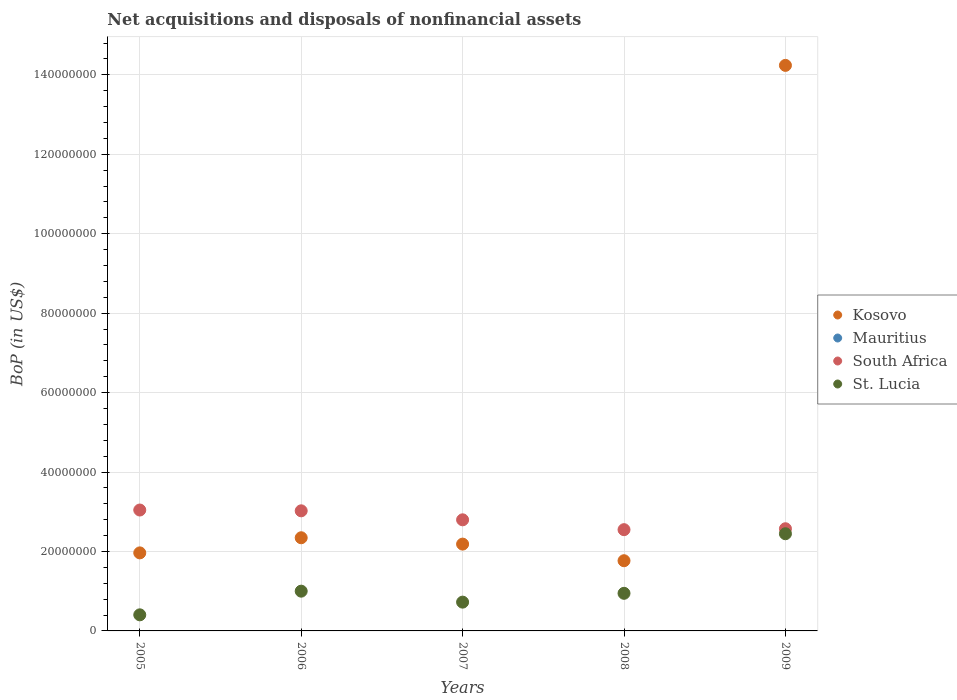How many different coloured dotlines are there?
Your answer should be very brief. 3. What is the Balance of Payments in South Africa in 2007?
Offer a terse response. 2.80e+07. Across all years, what is the maximum Balance of Payments in South Africa?
Your response must be concise. 3.04e+07. Across all years, what is the minimum Balance of Payments in St. Lucia?
Your response must be concise. 4.05e+06. What is the total Balance of Payments in South Africa in the graph?
Your answer should be very brief. 1.40e+08. What is the difference between the Balance of Payments in Kosovo in 2007 and that in 2008?
Offer a terse response. 4.18e+06. What is the difference between the Balance of Payments in Mauritius in 2005 and the Balance of Payments in St. Lucia in 2008?
Your answer should be compact. -9.47e+06. What is the average Balance of Payments in St. Lucia per year?
Your answer should be very brief. 1.10e+07. In the year 2009, what is the difference between the Balance of Payments in St. Lucia and Balance of Payments in South Africa?
Keep it short and to the point. -1.26e+06. What is the ratio of the Balance of Payments in St. Lucia in 2006 to that in 2009?
Your response must be concise. 0.41. Is the Balance of Payments in St. Lucia in 2005 less than that in 2006?
Your answer should be compact. Yes. Is the difference between the Balance of Payments in St. Lucia in 2008 and 2009 greater than the difference between the Balance of Payments in South Africa in 2008 and 2009?
Make the answer very short. No. What is the difference between the highest and the second highest Balance of Payments in Kosovo?
Your answer should be compact. 1.19e+08. What is the difference between the highest and the lowest Balance of Payments in St. Lucia?
Provide a succinct answer. 2.04e+07. Is the sum of the Balance of Payments in Kosovo in 2005 and 2009 greater than the maximum Balance of Payments in South Africa across all years?
Offer a terse response. Yes. Is it the case that in every year, the sum of the Balance of Payments in Kosovo and Balance of Payments in St. Lucia  is greater than the sum of Balance of Payments in Mauritius and Balance of Payments in South Africa?
Ensure brevity in your answer.  No. Does the Balance of Payments in Kosovo monotonically increase over the years?
Your response must be concise. No. Is the Balance of Payments in Kosovo strictly greater than the Balance of Payments in Mauritius over the years?
Your response must be concise. Yes. How many dotlines are there?
Give a very brief answer. 3. What is the difference between two consecutive major ticks on the Y-axis?
Your response must be concise. 2.00e+07. Does the graph contain any zero values?
Make the answer very short. Yes. Where does the legend appear in the graph?
Your response must be concise. Center right. How many legend labels are there?
Your response must be concise. 4. How are the legend labels stacked?
Your answer should be very brief. Vertical. What is the title of the graph?
Your answer should be compact. Net acquisitions and disposals of nonfinancial assets. Does "United States" appear as one of the legend labels in the graph?
Your answer should be compact. No. What is the label or title of the X-axis?
Your answer should be compact. Years. What is the label or title of the Y-axis?
Offer a very short reply. BoP (in US$). What is the BoP (in US$) of Kosovo in 2005?
Your response must be concise. 1.96e+07. What is the BoP (in US$) of South Africa in 2005?
Ensure brevity in your answer.  3.04e+07. What is the BoP (in US$) in St. Lucia in 2005?
Keep it short and to the point. 4.05e+06. What is the BoP (in US$) of Kosovo in 2006?
Your answer should be very brief. 2.35e+07. What is the BoP (in US$) of Mauritius in 2006?
Provide a succinct answer. 0. What is the BoP (in US$) in South Africa in 2006?
Make the answer very short. 3.02e+07. What is the BoP (in US$) of St. Lucia in 2006?
Give a very brief answer. 1.00e+07. What is the BoP (in US$) in Kosovo in 2007?
Provide a succinct answer. 2.19e+07. What is the BoP (in US$) of Mauritius in 2007?
Provide a succinct answer. 0. What is the BoP (in US$) of South Africa in 2007?
Your response must be concise. 2.80e+07. What is the BoP (in US$) of St. Lucia in 2007?
Your answer should be very brief. 7.25e+06. What is the BoP (in US$) in Kosovo in 2008?
Your answer should be compact. 1.77e+07. What is the BoP (in US$) in Mauritius in 2008?
Keep it short and to the point. 0. What is the BoP (in US$) of South Africa in 2008?
Offer a very short reply. 2.55e+07. What is the BoP (in US$) in St. Lucia in 2008?
Make the answer very short. 9.47e+06. What is the BoP (in US$) in Kosovo in 2009?
Provide a succinct answer. 1.42e+08. What is the BoP (in US$) of Mauritius in 2009?
Your response must be concise. 0. What is the BoP (in US$) of South Africa in 2009?
Provide a succinct answer. 2.57e+07. What is the BoP (in US$) of St. Lucia in 2009?
Your response must be concise. 2.45e+07. Across all years, what is the maximum BoP (in US$) in Kosovo?
Give a very brief answer. 1.42e+08. Across all years, what is the maximum BoP (in US$) in South Africa?
Provide a succinct answer. 3.04e+07. Across all years, what is the maximum BoP (in US$) in St. Lucia?
Your answer should be compact. 2.45e+07. Across all years, what is the minimum BoP (in US$) of Kosovo?
Give a very brief answer. 1.77e+07. Across all years, what is the minimum BoP (in US$) of South Africa?
Make the answer very short. 2.55e+07. Across all years, what is the minimum BoP (in US$) of St. Lucia?
Give a very brief answer. 4.05e+06. What is the total BoP (in US$) of Kosovo in the graph?
Give a very brief answer. 2.25e+08. What is the total BoP (in US$) in Mauritius in the graph?
Make the answer very short. 0. What is the total BoP (in US$) in South Africa in the graph?
Offer a very short reply. 1.40e+08. What is the total BoP (in US$) of St. Lucia in the graph?
Ensure brevity in your answer.  5.52e+07. What is the difference between the BoP (in US$) of Kosovo in 2005 and that in 2006?
Provide a short and direct response. -3.81e+06. What is the difference between the BoP (in US$) in South Africa in 2005 and that in 2006?
Keep it short and to the point. 2.02e+05. What is the difference between the BoP (in US$) of St. Lucia in 2005 and that in 2006?
Offer a terse response. -5.96e+06. What is the difference between the BoP (in US$) of Kosovo in 2005 and that in 2007?
Offer a very short reply. -2.21e+06. What is the difference between the BoP (in US$) in South Africa in 2005 and that in 2007?
Make the answer very short. 2.47e+06. What is the difference between the BoP (in US$) in St. Lucia in 2005 and that in 2007?
Your response must be concise. -3.20e+06. What is the difference between the BoP (in US$) in Kosovo in 2005 and that in 2008?
Provide a succinct answer. 1.97e+06. What is the difference between the BoP (in US$) of South Africa in 2005 and that in 2008?
Offer a very short reply. 4.95e+06. What is the difference between the BoP (in US$) in St. Lucia in 2005 and that in 2008?
Make the answer very short. -5.42e+06. What is the difference between the BoP (in US$) of Kosovo in 2005 and that in 2009?
Your answer should be compact. -1.23e+08. What is the difference between the BoP (in US$) in South Africa in 2005 and that in 2009?
Give a very brief answer. 4.71e+06. What is the difference between the BoP (in US$) in St. Lucia in 2005 and that in 2009?
Ensure brevity in your answer.  -2.04e+07. What is the difference between the BoP (in US$) in Kosovo in 2006 and that in 2007?
Make the answer very short. 1.60e+06. What is the difference between the BoP (in US$) in South Africa in 2006 and that in 2007?
Provide a succinct answer. 2.26e+06. What is the difference between the BoP (in US$) of St. Lucia in 2006 and that in 2007?
Offer a very short reply. 2.76e+06. What is the difference between the BoP (in US$) in Kosovo in 2006 and that in 2008?
Provide a short and direct response. 5.78e+06. What is the difference between the BoP (in US$) in South Africa in 2006 and that in 2008?
Provide a succinct answer. 4.74e+06. What is the difference between the BoP (in US$) of St. Lucia in 2006 and that in 2008?
Ensure brevity in your answer.  5.42e+05. What is the difference between the BoP (in US$) in Kosovo in 2006 and that in 2009?
Your answer should be compact. -1.19e+08. What is the difference between the BoP (in US$) of South Africa in 2006 and that in 2009?
Give a very brief answer. 4.51e+06. What is the difference between the BoP (in US$) in St. Lucia in 2006 and that in 2009?
Give a very brief answer. -1.45e+07. What is the difference between the BoP (in US$) in Kosovo in 2007 and that in 2008?
Give a very brief answer. 4.18e+06. What is the difference between the BoP (in US$) of South Africa in 2007 and that in 2008?
Keep it short and to the point. 2.48e+06. What is the difference between the BoP (in US$) in St. Lucia in 2007 and that in 2008?
Offer a terse response. -2.22e+06. What is the difference between the BoP (in US$) of Kosovo in 2007 and that in 2009?
Your response must be concise. -1.21e+08. What is the difference between the BoP (in US$) of South Africa in 2007 and that in 2009?
Give a very brief answer. 2.25e+06. What is the difference between the BoP (in US$) of St. Lucia in 2007 and that in 2009?
Offer a terse response. -1.72e+07. What is the difference between the BoP (in US$) of Kosovo in 2008 and that in 2009?
Provide a succinct answer. -1.25e+08. What is the difference between the BoP (in US$) of South Africa in 2008 and that in 2009?
Your answer should be compact. -2.34e+05. What is the difference between the BoP (in US$) in St. Lucia in 2008 and that in 2009?
Your response must be concise. -1.50e+07. What is the difference between the BoP (in US$) in Kosovo in 2005 and the BoP (in US$) in South Africa in 2006?
Give a very brief answer. -1.06e+07. What is the difference between the BoP (in US$) in Kosovo in 2005 and the BoP (in US$) in St. Lucia in 2006?
Provide a short and direct response. 9.64e+06. What is the difference between the BoP (in US$) in South Africa in 2005 and the BoP (in US$) in St. Lucia in 2006?
Your answer should be very brief. 2.04e+07. What is the difference between the BoP (in US$) in Kosovo in 2005 and the BoP (in US$) in South Africa in 2007?
Offer a terse response. -8.33e+06. What is the difference between the BoP (in US$) of Kosovo in 2005 and the BoP (in US$) of St. Lucia in 2007?
Your answer should be compact. 1.24e+07. What is the difference between the BoP (in US$) in South Africa in 2005 and the BoP (in US$) in St. Lucia in 2007?
Offer a terse response. 2.32e+07. What is the difference between the BoP (in US$) of Kosovo in 2005 and the BoP (in US$) of South Africa in 2008?
Offer a terse response. -5.85e+06. What is the difference between the BoP (in US$) in Kosovo in 2005 and the BoP (in US$) in St. Lucia in 2008?
Your answer should be compact. 1.02e+07. What is the difference between the BoP (in US$) of South Africa in 2005 and the BoP (in US$) of St. Lucia in 2008?
Keep it short and to the point. 2.10e+07. What is the difference between the BoP (in US$) in Kosovo in 2005 and the BoP (in US$) in South Africa in 2009?
Offer a very short reply. -6.08e+06. What is the difference between the BoP (in US$) of Kosovo in 2005 and the BoP (in US$) of St. Lucia in 2009?
Offer a terse response. -4.82e+06. What is the difference between the BoP (in US$) of South Africa in 2005 and the BoP (in US$) of St. Lucia in 2009?
Offer a very short reply. 5.97e+06. What is the difference between the BoP (in US$) of Kosovo in 2006 and the BoP (in US$) of South Africa in 2007?
Offer a very short reply. -4.52e+06. What is the difference between the BoP (in US$) in Kosovo in 2006 and the BoP (in US$) in St. Lucia in 2007?
Make the answer very short. 1.62e+07. What is the difference between the BoP (in US$) of South Africa in 2006 and the BoP (in US$) of St. Lucia in 2007?
Offer a very short reply. 2.30e+07. What is the difference between the BoP (in US$) in Kosovo in 2006 and the BoP (in US$) in South Africa in 2008?
Provide a short and direct response. -2.04e+06. What is the difference between the BoP (in US$) of Kosovo in 2006 and the BoP (in US$) of St. Lucia in 2008?
Your answer should be very brief. 1.40e+07. What is the difference between the BoP (in US$) in South Africa in 2006 and the BoP (in US$) in St. Lucia in 2008?
Your answer should be compact. 2.08e+07. What is the difference between the BoP (in US$) in Kosovo in 2006 and the BoP (in US$) in South Africa in 2009?
Provide a succinct answer. -2.27e+06. What is the difference between the BoP (in US$) in Kosovo in 2006 and the BoP (in US$) in St. Lucia in 2009?
Offer a very short reply. -1.01e+06. What is the difference between the BoP (in US$) of South Africa in 2006 and the BoP (in US$) of St. Lucia in 2009?
Give a very brief answer. 5.77e+06. What is the difference between the BoP (in US$) in Kosovo in 2007 and the BoP (in US$) in South Africa in 2008?
Offer a very short reply. -3.64e+06. What is the difference between the BoP (in US$) of Kosovo in 2007 and the BoP (in US$) of St. Lucia in 2008?
Your answer should be compact. 1.24e+07. What is the difference between the BoP (in US$) of South Africa in 2007 and the BoP (in US$) of St. Lucia in 2008?
Make the answer very short. 1.85e+07. What is the difference between the BoP (in US$) of Kosovo in 2007 and the BoP (in US$) of South Africa in 2009?
Offer a terse response. -3.87e+06. What is the difference between the BoP (in US$) in Kosovo in 2007 and the BoP (in US$) in St. Lucia in 2009?
Keep it short and to the point. -2.61e+06. What is the difference between the BoP (in US$) of South Africa in 2007 and the BoP (in US$) of St. Lucia in 2009?
Your response must be concise. 3.51e+06. What is the difference between the BoP (in US$) of Kosovo in 2008 and the BoP (in US$) of South Africa in 2009?
Make the answer very short. -8.05e+06. What is the difference between the BoP (in US$) of Kosovo in 2008 and the BoP (in US$) of St. Lucia in 2009?
Give a very brief answer. -6.79e+06. What is the difference between the BoP (in US$) of South Africa in 2008 and the BoP (in US$) of St. Lucia in 2009?
Provide a short and direct response. 1.03e+06. What is the average BoP (in US$) in Kosovo per year?
Your response must be concise. 4.50e+07. What is the average BoP (in US$) of Mauritius per year?
Give a very brief answer. 0. What is the average BoP (in US$) in South Africa per year?
Ensure brevity in your answer.  2.80e+07. What is the average BoP (in US$) of St. Lucia per year?
Give a very brief answer. 1.10e+07. In the year 2005, what is the difference between the BoP (in US$) in Kosovo and BoP (in US$) in South Africa?
Keep it short and to the point. -1.08e+07. In the year 2005, what is the difference between the BoP (in US$) in Kosovo and BoP (in US$) in St. Lucia?
Your answer should be very brief. 1.56e+07. In the year 2005, what is the difference between the BoP (in US$) in South Africa and BoP (in US$) in St. Lucia?
Make the answer very short. 2.64e+07. In the year 2006, what is the difference between the BoP (in US$) of Kosovo and BoP (in US$) of South Africa?
Ensure brevity in your answer.  -6.78e+06. In the year 2006, what is the difference between the BoP (in US$) in Kosovo and BoP (in US$) in St. Lucia?
Your response must be concise. 1.34e+07. In the year 2006, what is the difference between the BoP (in US$) of South Africa and BoP (in US$) of St. Lucia?
Provide a succinct answer. 2.02e+07. In the year 2007, what is the difference between the BoP (in US$) in Kosovo and BoP (in US$) in South Africa?
Keep it short and to the point. -6.12e+06. In the year 2007, what is the difference between the BoP (in US$) of Kosovo and BoP (in US$) of St. Lucia?
Ensure brevity in your answer.  1.46e+07. In the year 2007, what is the difference between the BoP (in US$) in South Africa and BoP (in US$) in St. Lucia?
Offer a very short reply. 2.07e+07. In the year 2008, what is the difference between the BoP (in US$) in Kosovo and BoP (in US$) in South Africa?
Your response must be concise. -7.82e+06. In the year 2008, what is the difference between the BoP (in US$) in Kosovo and BoP (in US$) in St. Lucia?
Your response must be concise. 8.21e+06. In the year 2008, what is the difference between the BoP (in US$) of South Africa and BoP (in US$) of St. Lucia?
Ensure brevity in your answer.  1.60e+07. In the year 2009, what is the difference between the BoP (in US$) in Kosovo and BoP (in US$) in South Africa?
Offer a terse response. 1.17e+08. In the year 2009, what is the difference between the BoP (in US$) of Kosovo and BoP (in US$) of St. Lucia?
Your response must be concise. 1.18e+08. In the year 2009, what is the difference between the BoP (in US$) in South Africa and BoP (in US$) in St. Lucia?
Provide a short and direct response. 1.26e+06. What is the ratio of the BoP (in US$) in Kosovo in 2005 to that in 2006?
Give a very brief answer. 0.84. What is the ratio of the BoP (in US$) of St. Lucia in 2005 to that in 2006?
Offer a terse response. 0.4. What is the ratio of the BoP (in US$) in Kosovo in 2005 to that in 2007?
Give a very brief answer. 0.9. What is the ratio of the BoP (in US$) of South Africa in 2005 to that in 2007?
Provide a short and direct response. 1.09. What is the ratio of the BoP (in US$) of St. Lucia in 2005 to that in 2007?
Offer a very short reply. 0.56. What is the ratio of the BoP (in US$) of Kosovo in 2005 to that in 2008?
Keep it short and to the point. 1.11. What is the ratio of the BoP (in US$) in South Africa in 2005 to that in 2008?
Offer a terse response. 1.19. What is the ratio of the BoP (in US$) of St. Lucia in 2005 to that in 2008?
Provide a succinct answer. 0.43. What is the ratio of the BoP (in US$) of Kosovo in 2005 to that in 2009?
Offer a very short reply. 0.14. What is the ratio of the BoP (in US$) of South Africa in 2005 to that in 2009?
Ensure brevity in your answer.  1.18. What is the ratio of the BoP (in US$) in St. Lucia in 2005 to that in 2009?
Your answer should be very brief. 0.17. What is the ratio of the BoP (in US$) in Kosovo in 2006 to that in 2007?
Provide a succinct answer. 1.07. What is the ratio of the BoP (in US$) of South Africa in 2006 to that in 2007?
Provide a short and direct response. 1.08. What is the ratio of the BoP (in US$) in St. Lucia in 2006 to that in 2007?
Offer a terse response. 1.38. What is the ratio of the BoP (in US$) of Kosovo in 2006 to that in 2008?
Your answer should be very brief. 1.33. What is the ratio of the BoP (in US$) of South Africa in 2006 to that in 2008?
Provide a short and direct response. 1.19. What is the ratio of the BoP (in US$) in St. Lucia in 2006 to that in 2008?
Your answer should be compact. 1.06. What is the ratio of the BoP (in US$) in Kosovo in 2006 to that in 2009?
Your answer should be very brief. 0.16. What is the ratio of the BoP (in US$) in South Africa in 2006 to that in 2009?
Give a very brief answer. 1.18. What is the ratio of the BoP (in US$) in St. Lucia in 2006 to that in 2009?
Provide a succinct answer. 0.41. What is the ratio of the BoP (in US$) of Kosovo in 2007 to that in 2008?
Your response must be concise. 1.24. What is the ratio of the BoP (in US$) of South Africa in 2007 to that in 2008?
Provide a succinct answer. 1.1. What is the ratio of the BoP (in US$) in St. Lucia in 2007 to that in 2008?
Provide a succinct answer. 0.77. What is the ratio of the BoP (in US$) of Kosovo in 2007 to that in 2009?
Make the answer very short. 0.15. What is the ratio of the BoP (in US$) of South Africa in 2007 to that in 2009?
Give a very brief answer. 1.09. What is the ratio of the BoP (in US$) in St. Lucia in 2007 to that in 2009?
Provide a succinct answer. 0.3. What is the ratio of the BoP (in US$) in Kosovo in 2008 to that in 2009?
Provide a short and direct response. 0.12. What is the ratio of the BoP (in US$) in South Africa in 2008 to that in 2009?
Offer a terse response. 0.99. What is the ratio of the BoP (in US$) in St. Lucia in 2008 to that in 2009?
Offer a very short reply. 0.39. What is the difference between the highest and the second highest BoP (in US$) of Kosovo?
Your response must be concise. 1.19e+08. What is the difference between the highest and the second highest BoP (in US$) of South Africa?
Make the answer very short. 2.02e+05. What is the difference between the highest and the second highest BoP (in US$) of St. Lucia?
Keep it short and to the point. 1.45e+07. What is the difference between the highest and the lowest BoP (in US$) of Kosovo?
Provide a succinct answer. 1.25e+08. What is the difference between the highest and the lowest BoP (in US$) of South Africa?
Your answer should be compact. 4.95e+06. What is the difference between the highest and the lowest BoP (in US$) of St. Lucia?
Provide a succinct answer. 2.04e+07. 